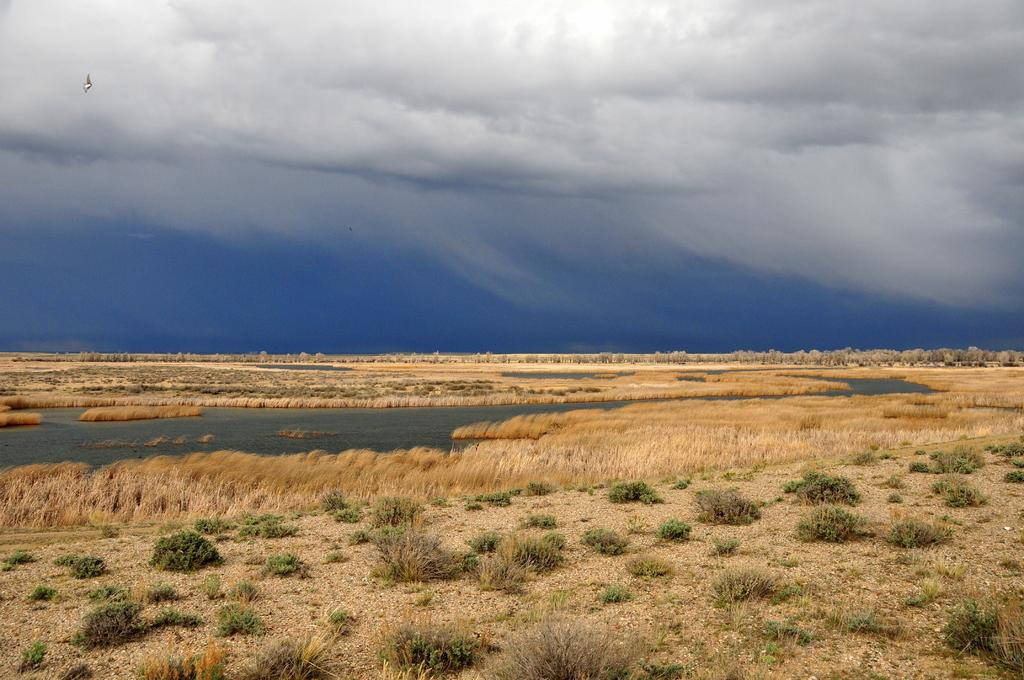What type of vegetation is present on the ground in the image? There is grass and plants on the ground in the image. What natural element can be seen besides the vegetation? There is water visible in the image. What is visible in the sky in the background? There are clouds in the sky in the background. What type of toad can be seen driving a car in the image? There is no toad or car present in the image. What topic are the clouds discussing in the background? Clouds do not have the ability to discuss topics, and there is no discussion taking place in the image. 